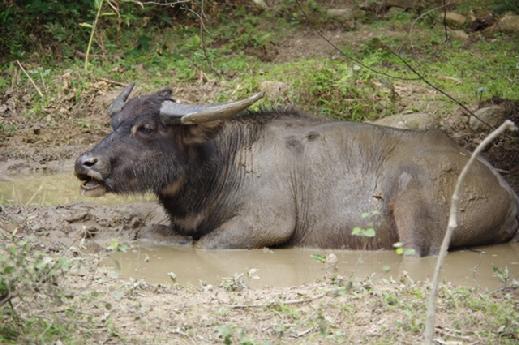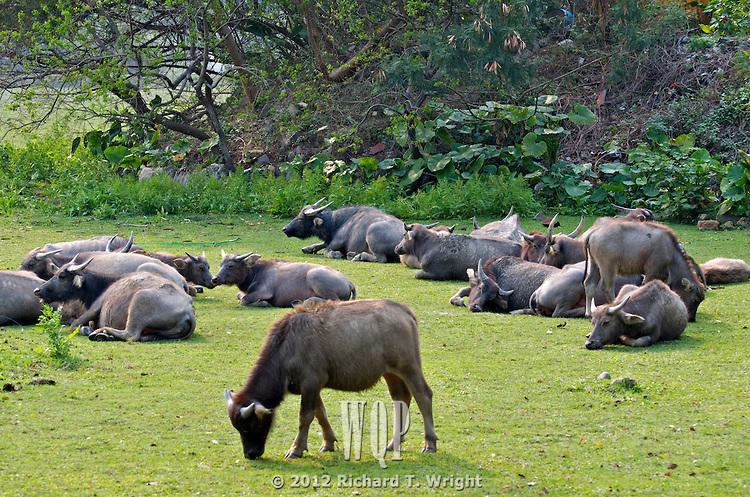The first image is the image on the left, the second image is the image on the right. Considering the images on both sides, is "There are animals but no humans on both pictures." valid? Answer yes or no. Yes. The first image is the image on the left, the second image is the image on the right. Analyze the images presented: Is the assertion "An image with reclining water buffalo includes at least one bird, which is not in flight." valid? Answer yes or no. No. 